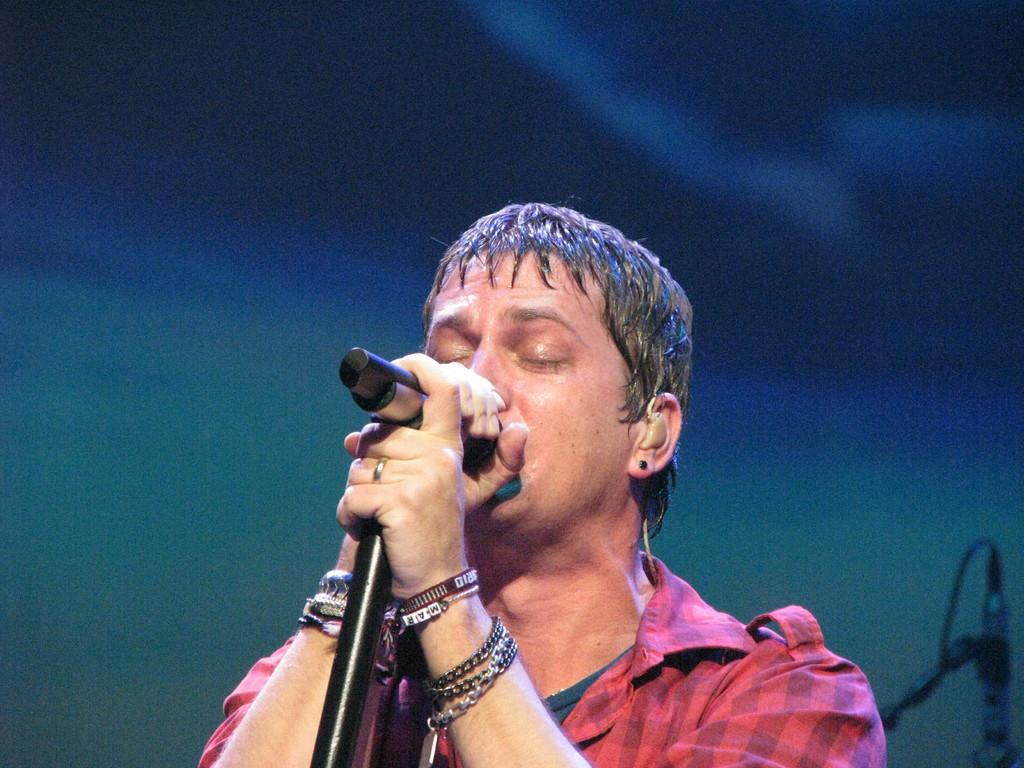What is the main subject of the image? There is a man in the image. What is the man holding in the image? The man is holding a mic. What color is the shirt the man is wearing? The man is wearing a red-colored shirt. How many ants can be seen crawling on the man's wrist in the image? There are no ants visible in the image, and the man's wrist is not mentioned in the provided facts. 